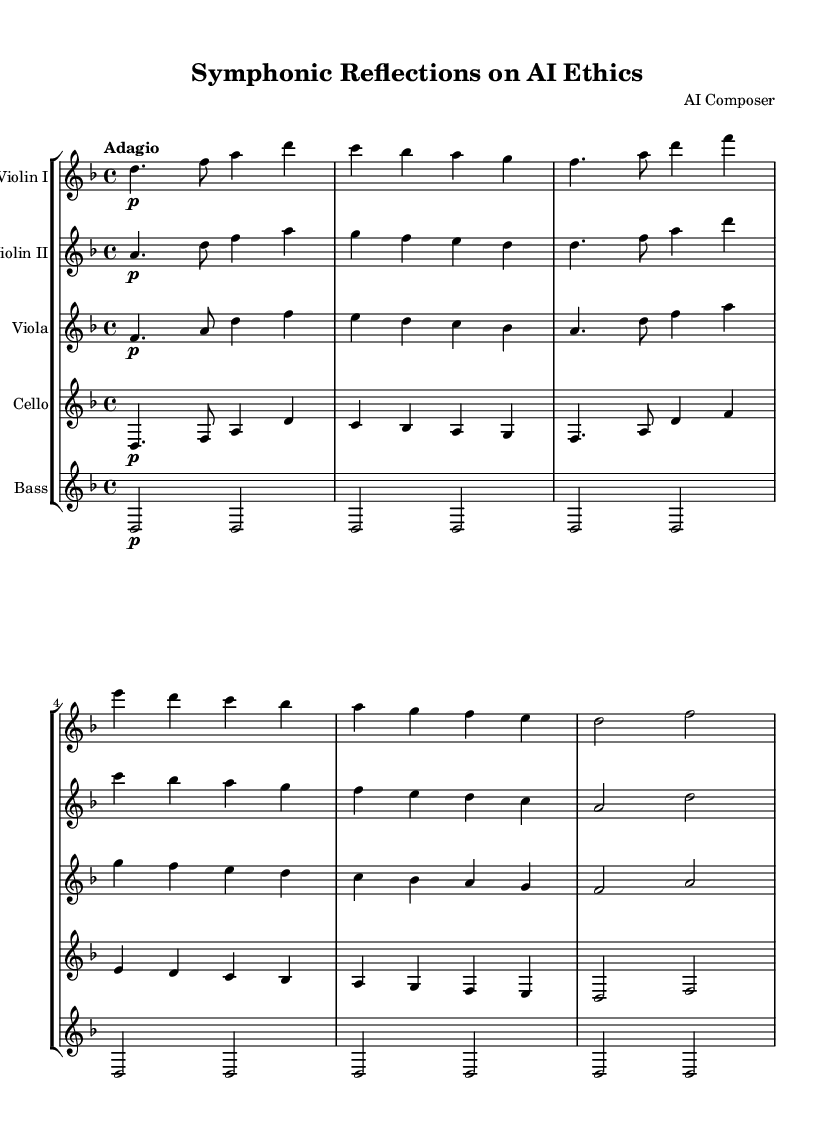What is the key signature of this music? The key signature is indicated by the number of sharps and flats at the beginning of the staff. In this case, there is one flat (B flat), which denotes D minor.
Answer: D minor What is the time signature of this music? The time signature is indicated by the numbers located at the beginning of the score. Here, it shows 4 over 4, meaning there are four beats in each measure.
Answer: 4/4 What is the tempo marking given in the score? The tempo marking is provided above the musical staff, indicating the speed at which the piece should be played. In this score, it says "Adagio," which means slow.
Answer: Adagio Which instruments are present in this score? The instruments can be identified by their respective staff names in the score. In this case, the instruments listed are Violin I, Violin II, Viola, Cello, and Bass.
Answer: Violin I, Violin II, Viola, Cello, Bass How many measures are written for Violin II? To find the number of measures, count the number of times the music is divided into distinct sections on the staff for Violin II. The score appears to have 5 measures for Violin II.
Answer: 5 What is the dynamic marking for the cello part? The dynamic marking indicates the volume and emotional intensity of the music. In this score, the cello part begins with a "p" indicating a soft dynamic (piano).
Answer: Piano Which instrument plays the lowest pitch in this score? To determine which instrument has the lowest pitch, look at the clefs used and the pitches written in each staff. The Bass typically plays the lowest pitches among the instruments presented here.
Answer: Bass 